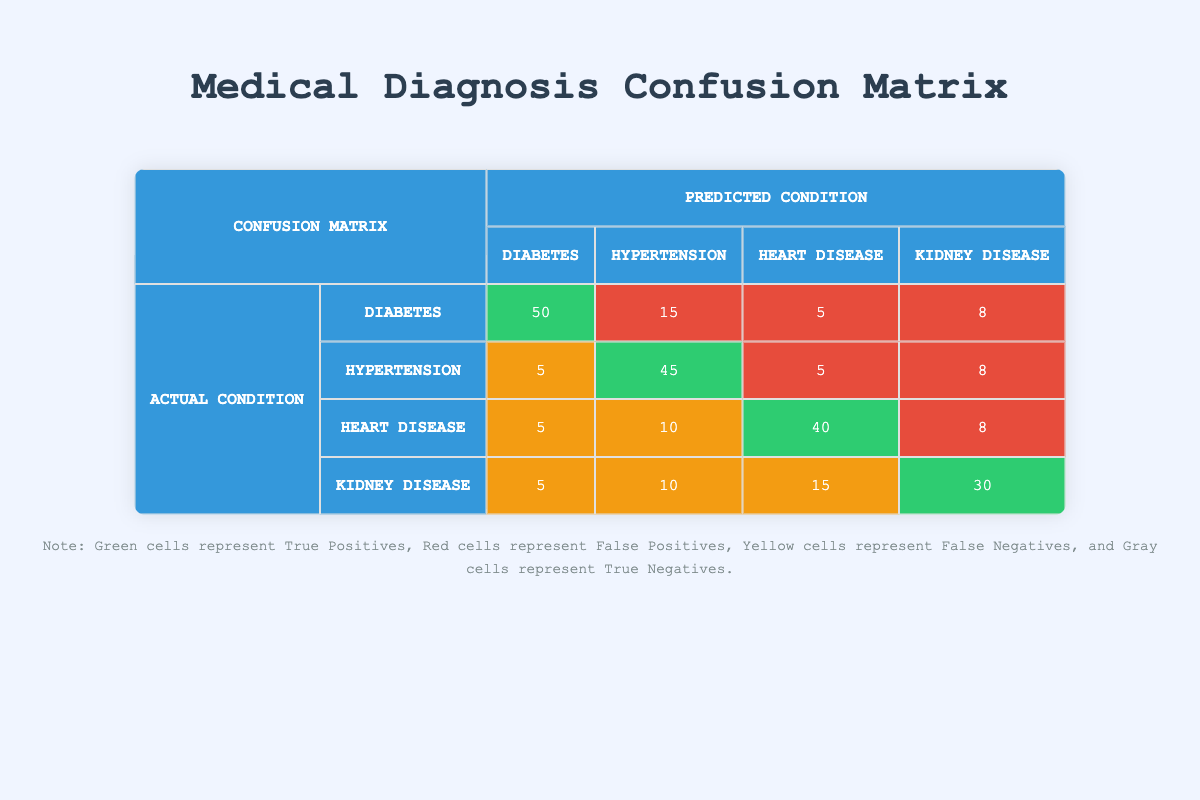What is the True Positive count for Diabetes? The table lists the True Positive count for Diabetes under the column labeled "Diabetes" in the row for "Diabetes". The value found is 50.
Answer: 50 What is the False Negative count for Heart Disease? The table specifies the False Negative count for Heart Disease in the row corresponding to this condition. The number indicated is 15.
Answer: 15 Which condition had the highest False Positives? To determine this, compare the False Positive counts across all conditions: Diabetes has 10, Hypertension has 15, Heart Disease has 5, and Kidney Disease has 8. The highest value is 15 under Hypertension.
Answer: Hypertension What is the combined True Positive count for all diseases? To find the total True Positive count, sum the True Positives for each disease: 50 (Diabetes) + 45 (Hypertension) + 40 (Heart Disease) + 30 (Kidney Disease) = 165.
Answer: 165 Is the number of True Negatives for Kidney Disease greater than that for Hypertension? The True Negatives for Kidney Disease is 37 and for Hypertension is 25. Since 37 is greater than 25, the statement is true.
Answer: Yes What is the average False Positive count across all diseases? The False Positives for each condition are 10 (Diabetes), 15 (Hypertension), 5 (Heart Disease), and 8 (Kidney Disease). Add these together: 10 + 15 + 5 + 8 = 38. Then, divide by 4 (the number of diseases): 38 / 4 = 9.5.
Answer: 9.5 What condition has the highest True Positive count and what is that count? Analyzing the True Positive counts: 50 for Diabetes, 45 for Hypertension, 40 for Heart Disease, and 30 for Kidney Disease. The highest count is 50 for Diabetes.
Answer: Diabetes, 50 How many total cases were incorrectly identified (False Positives + False Negatives) for Heart Disease? The False Positives for Heart Disease is 5, and the False Negatives is 15. Adding these together: 5 + 15 equals 20 cases were incorrectly identified.
Answer: 20 What percentage of the actual cases of Hypertension were correctly diagnosed as True Positives? The True Positive count for Hypertension is 45, and the total actual cases for Hypertension (True Positives + False Negatives) is 45 + 10 = 55. The percentage is calculated by (45 / 55) * 100, which equals approximately 81.82%.
Answer: 81.82% 